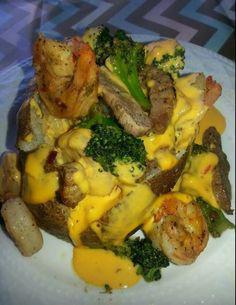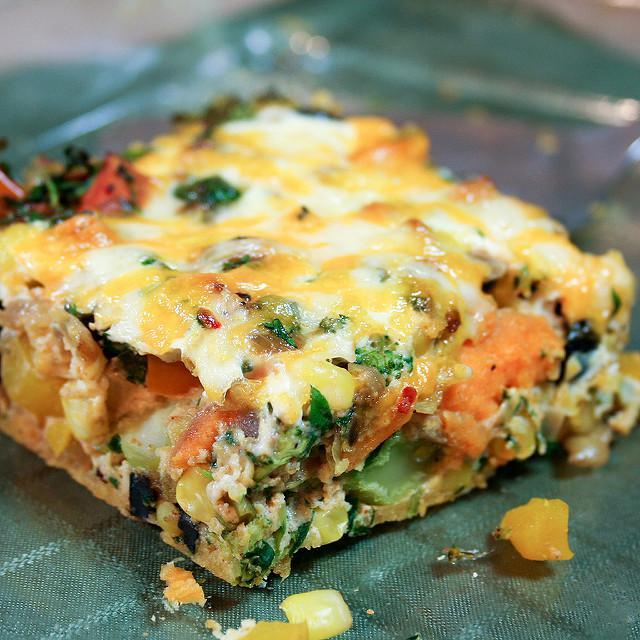The first image is the image on the left, the second image is the image on the right. For the images shown, is this caption "There is one piece of food on the dish on the right." true? Answer yes or no. Yes. The first image is the image on the left, the second image is the image on the right. Given the left and right images, does the statement "Each image contains at least three baked stuffed potato." hold true? Answer yes or no. No. 